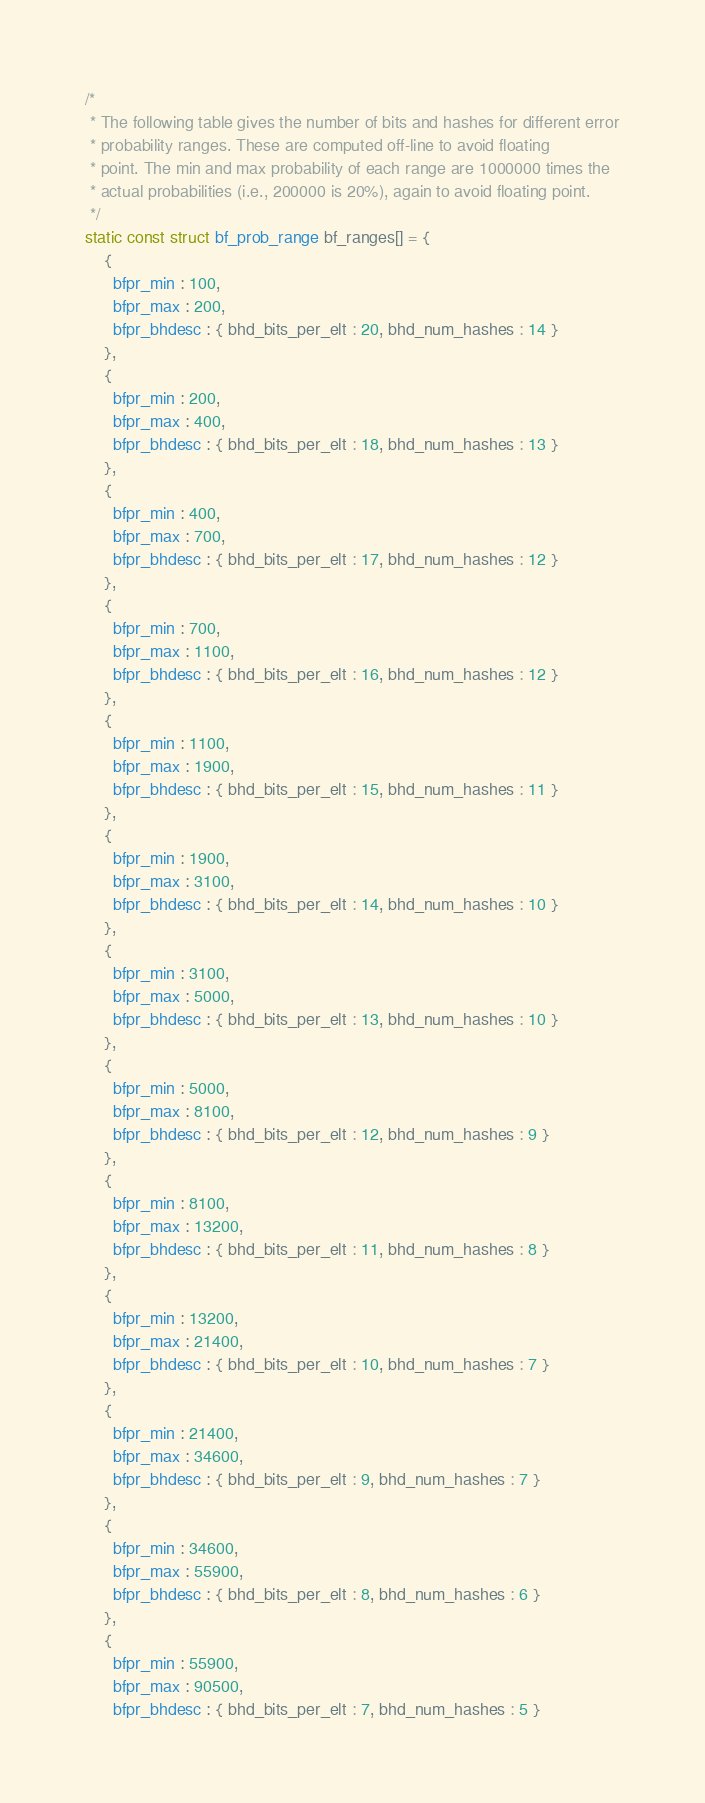Convert code to text. <code><loc_0><loc_0><loc_500><loc_500><_C_>
/*
 * The following table gives the number of bits and hashes for different error
 * probability ranges. These are computed off-line to avoid floating
 * point. The min and max probability of each range are 1000000 times the
 * actual probabilities (i.e., 200000 is 20%), again to avoid floating point.
 */
static const struct bf_prob_range bf_ranges[] = {
    {
      bfpr_min : 100,
      bfpr_max : 200,
      bfpr_bhdesc : { bhd_bits_per_elt : 20, bhd_num_hashes : 14 }
    },
    {
      bfpr_min : 200,
      bfpr_max : 400,
      bfpr_bhdesc : { bhd_bits_per_elt : 18, bhd_num_hashes : 13 }
    },
    {
      bfpr_min : 400,
      bfpr_max : 700,
      bfpr_bhdesc : { bhd_bits_per_elt : 17, bhd_num_hashes : 12 }
    },
    {
      bfpr_min : 700,
      bfpr_max : 1100,
      bfpr_bhdesc : { bhd_bits_per_elt : 16, bhd_num_hashes : 12 }
    },
    {
      bfpr_min : 1100,
      bfpr_max : 1900,
      bfpr_bhdesc : { bhd_bits_per_elt : 15, bhd_num_hashes : 11 }
    },
    {
      bfpr_min : 1900,
      bfpr_max : 3100,
      bfpr_bhdesc : { bhd_bits_per_elt : 14, bhd_num_hashes : 10 }
    },
    {
      bfpr_min : 3100,
      bfpr_max : 5000,
      bfpr_bhdesc : { bhd_bits_per_elt : 13, bhd_num_hashes : 10 }
    },
    {
      bfpr_min : 5000,
      bfpr_max : 8100,
      bfpr_bhdesc : { bhd_bits_per_elt : 12, bhd_num_hashes : 9 }
    },
    {
      bfpr_min : 8100,
      bfpr_max : 13200,
      bfpr_bhdesc : { bhd_bits_per_elt : 11, bhd_num_hashes : 8 }
    },
    {
      bfpr_min : 13200,
      bfpr_max : 21400,
      bfpr_bhdesc : { bhd_bits_per_elt : 10, bhd_num_hashes : 7 }
    },
    {
      bfpr_min : 21400,
      bfpr_max : 34600,
      bfpr_bhdesc : { bhd_bits_per_elt : 9, bhd_num_hashes : 7 }
    },
    {
      bfpr_min : 34600,
      bfpr_max : 55900,
      bfpr_bhdesc : { bhd_bits_per_elt : 8, bhd_num_hashes : 6 }
    },
    {
      bfpr_min : 55900,
      bfpr_max : 90500,
      bfpr_bhdesc : { bhd_bits_per_elt : 7, bhd_num_hashes : 5 }</code> 